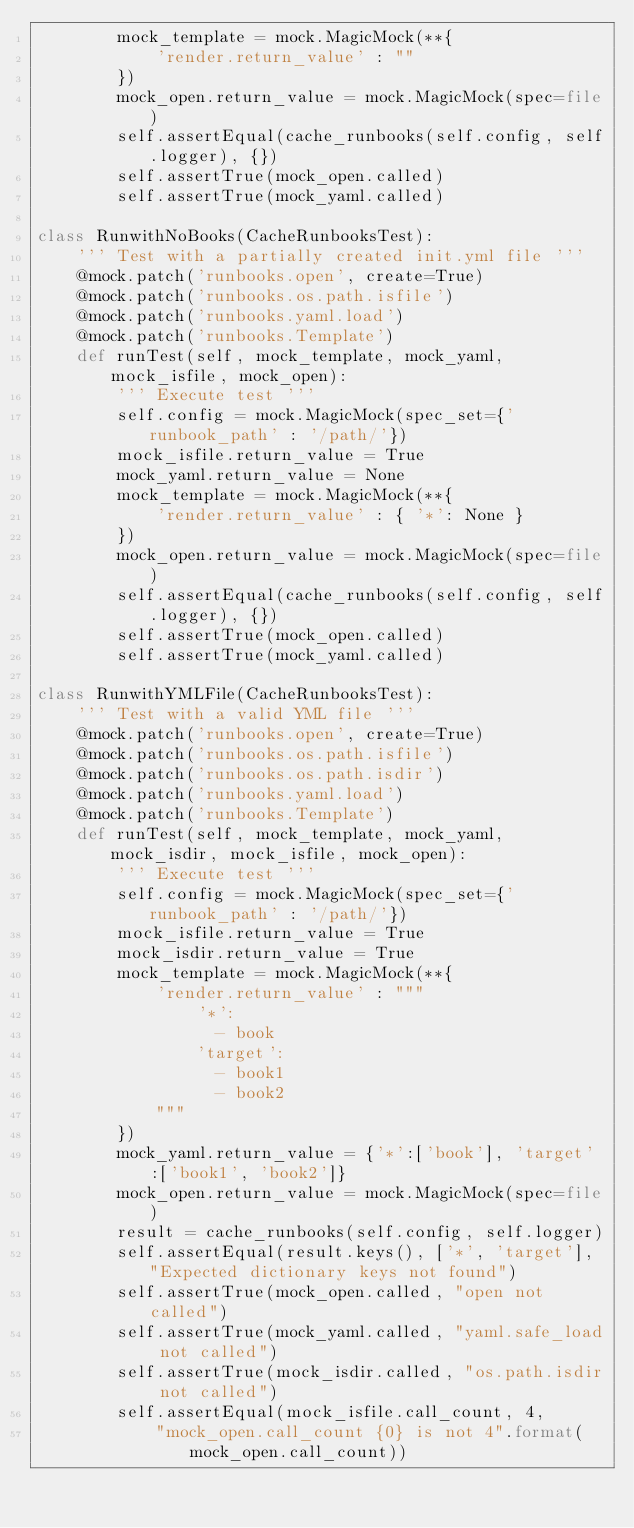<code> <loc_0><loc_0><loc_500><loc_500><_Python_>        mock_template = mock.MagicMock(**{
            'render.return_value' : ""
        })
        mock_open.return_value = mock.MagicMock(spec=file)
        self.assertEqual(cache_runbooks(self.config, self.logger), {})
        self.assertTrue(mock_open.called)
        self.assertTrue(mock_yaml.called)

class RunwithNoBooks(CacheRunbooksTest):
    ''' Test with a partially created init.yml file '''
    @mock.patch('runbooks.open', create=True)
    @mock.patch('runbooks.os.path.isfile')
    @mock.patch('runbooks.yaml.load')
    @mock.patch('runbooks.Template')
    def runTest(self, mock_template, mock_yaml, mock_isfile, mock_open):
        ''' Execute test '''
        self.config = mock.MagicMock(spec_set={'runbook_path' : '/path/'})
        mock_isfile.return_value = True
        mock_yaml.return_value = None
        mock_template = mock.MagicMock(**{
            'render.return_value' : { '*': None }
        })
        mock_open.return_value = mock.MagicMock(spec=file)
        self.assertEqual(cache_runbooks(self.config, self.logger), {})
        self.assertTrue(mock_open.called)
        self.assertTrue(mock_yaml.called)

class RunwithYMLFile(CacheRunbooksTest):
    ''' Test with a valid YML file '''
    @mock.patch('runbooks.open', create=True)
    @mock.patch('runbooks.os.path.isfile')
    @mock.patch('runbooks.os.path.isdir')
    @mock.patch('runbooks.yaml.load')
    @mock.patch('runbooks.Template')
    def runTest(self, mock_template, mock_yaml, mock_isdir, mock_isfile, mock_open):
        ''' Execute test '''
        self.config = mock.MagicMock(spec_set={'runbook_path' : '/path/'})
        mock_isfile.return_value = True
        mock_isdir.return_value = True
        mock_template = mock.MagicMock(**{
            'render.return_value' : """
                '*':
                  - book
                'target':
                  - book1
                  - book2
            """
        })
        mock_yaml.return_value = {'*':['book'], 'target':['book1', 'book2']}
        mock_open.return_value = mock.MagicMock(spec=file)
        result = cache_runbooks(self.config, self.logger)
        self.assertEqual(result.keys(), ['*', 'target'], "Expected dictionary keys not found")
        self.assertTrue(mock_open.called, "open not called")
        self.assertTrue(mock_yaml.called, "yaml.safe_load not called")
        self.assertTrue(mock_isdir.called, "os.path.isdir not called")
        self.assertEqual(mock_isfile.call_count, 4,
            "mock_open.call_count {0} is not 4".format(mock_open.call_count))
</code> 